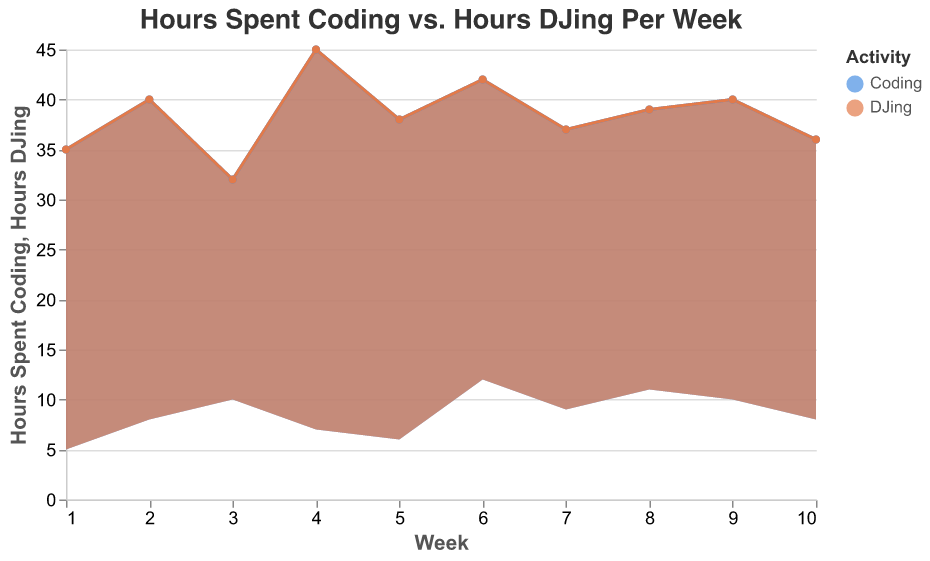What is the title of the area chart? The title of the area chart is located at the top of the figure and provides a concise description of what the chart is about.
Answer: Hours Spent Coding vs. Hours DJing Per Week What do the x and y axes represent respectively? The x-axis represents the weeks, ranging from Week 1 to Week 10. The y-axis represents the number of hours spent on the activities, specifically coding and DJing.
Answer: The x-axis represents weeks and the y-axis represents hours How many weeks does the data cover? By examining the x-axis, we observe that it ranges from Week 1 to Week 10, indicating that the data spans over 10 weeks.
Answer: 10 weeks Which week shows the highest number of hours spent coding? The peak of the area shading for coding can be found by identifying the week with the highest value on the y-axis for coding, which occurs during Week 4 with 45 hours.
Answer: Week 4 In which week were the hours spent DJing the highest? By examining the top points of the shading for DJing, we notice that Week 6 has the highest mark at 12 hours.
Answer: Week 6 What is the combined total of hours spent coding and DJing in Week 2? In Week 2, the hours spent coding is 40 and the hours spent DJing is 8. Adding them together, we get 40 + 8 = 48 hours.
Answer: 48 hours Between Week 7 and Week 8, which week had more hours spent on both activities combined? In Week 7, the sum of hours is 37 (coding) + 9 (DJing) = 46 hours. In Week 8, it is 39 (coding) + 11 (DJing) = 50 hours. Since 50 > 46, Week 8 had more hours combined.
Answer: Week 8 On average, how many hours were spent coding per week? To find the average, sum up all hours spent coding and divide by the number of weeks: (35 + 40 + 32 + 45 + 38 + 42 + 37 + 39 + 40 + 36) / 10 = 384 / 10 = 38.4 hours per week.
Answer: 38.4 hours per week How do the fluctuations in hours spent DJing compare with the fluctuations in hours spent coding? Hours spent DJing fluctuate more drastically from Week to Week compared to coding. Coding hours stay around the 35-45 range, while DJing hours range from 5 to 12. This can be seen by comparing the peaks and valleys of both activities' areas.
Answer: DJing fluctuates more Is there any week where the amount of time spent coding and DJing is equal? By observing the y-values for both activities across all weeks, it can be seen that no single week has equal hours spent coding and DJing.
Answer: No 